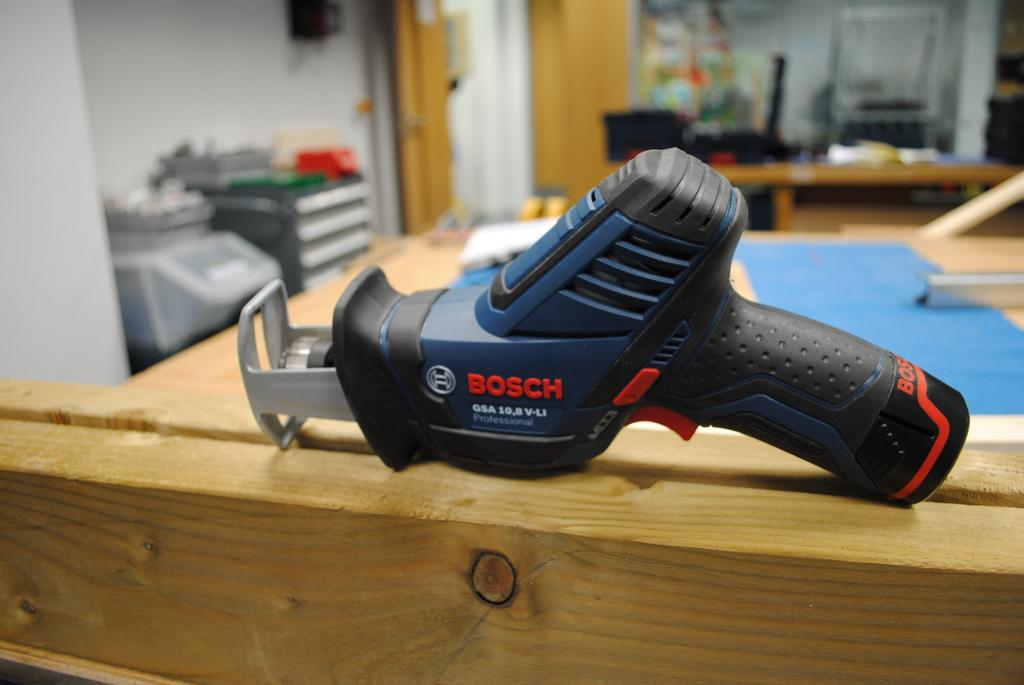What color is the drill machine in the image? The drill machine in the image is blue. Where is the drill machine placed? The drill machine is placed on wooden rafters. What other furniture or equipment can be seen in the image? There is a table and tool boxes in the image. What can be seen in the background of the image? There is a white wall and a wooden door in the background of the image. What type of banana is being used as a tool in the image? There is no banana present in the image; it is a drill machine and tool boxes that are being used. What company is responsible for the drill machine in the image? The image does not provide information about the company that manufactured the drill machine. 